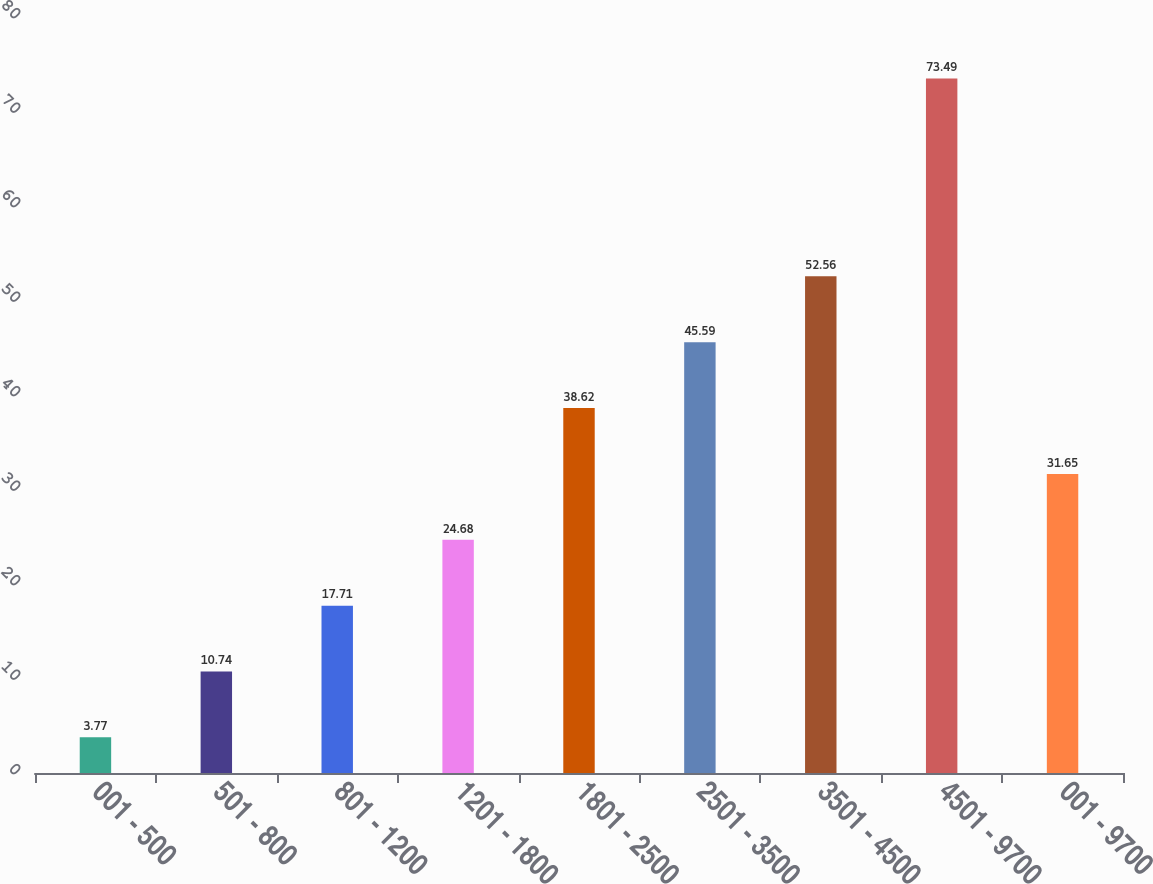<chart> <loc_0><loc_0><loc_500><loc_500><bar_chart><fcel>001 - 500<fcel>501 - 800<fcel>801 - 1200<fcel>1201 - 1800<fcel>1801 - 2500<fcel>2501 - 3500<fcel>3501 - 4500<fcel>4501 - 9700<fcel>001 - 9700<nl><fcel>3.77<fcel>10.74<fcel>17.71<fcel>24.68<fcel>38.62<fcel>45.59<fcel>52.56<fcel>73.49<fcel>31.65<nl></chart> 